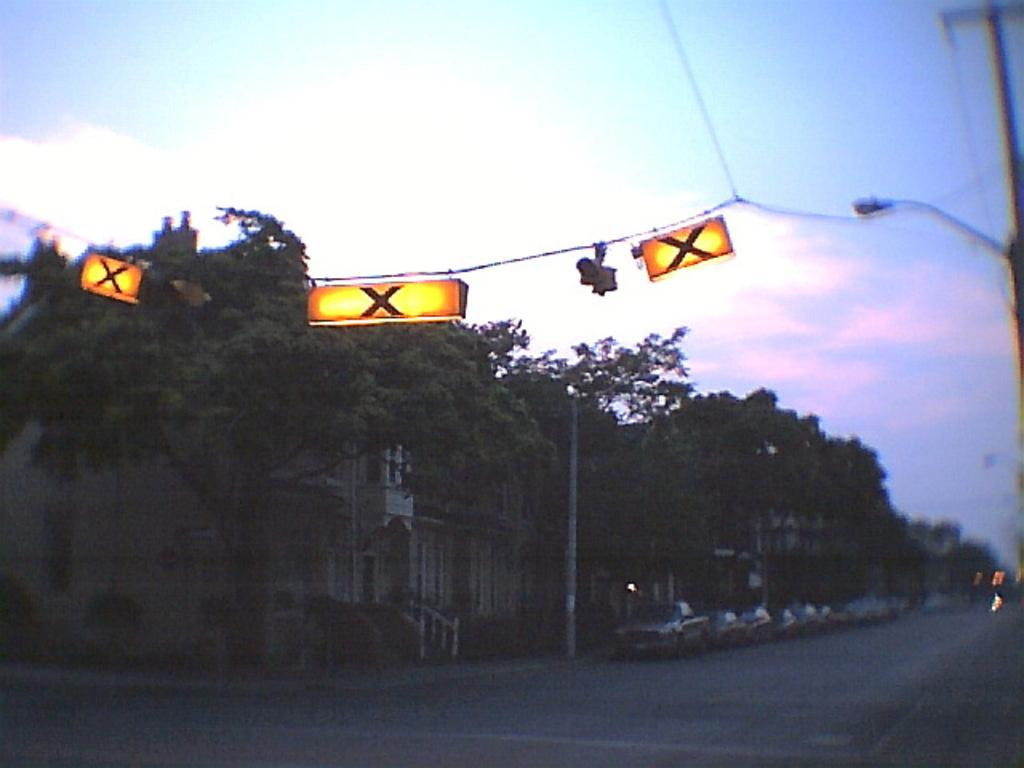What can be seen in the middle of the image? There are trees in the middle of the image. What other objects are present in the image? There are poles, street lights, cables, lights, vehicles, and buildings in the image. What is visible in the sky in the image? The sky is visible in the image, and there are clouds present. What day of the week is depicted in the image? The image does not depict a specific day of the week; it is a still image of a scene. What type of paste is being used to hold the street lights in the image? There is no paste present in the image; the street lights are attached to poles or buildings. 